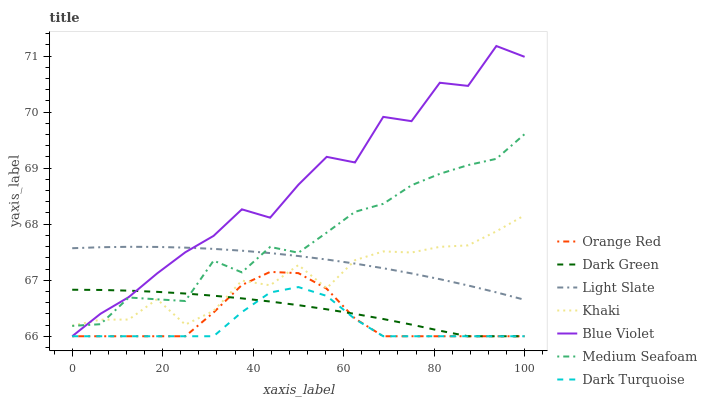Does Light Slate have the minimum area under the curve?
Answer yes or no. No. Does Light Slate have the maximum area under the curve?
Answer yes or no. No. Is Dark Turquoise the smoothest?
Answer yes or no. No. Is Dark Turquoise the roughest?
Answer yes or no. No. Does Light Slate have the lowest value?
Answer yes or no. No. Does Light Slate have the highest value?
Answer yes or no. No. Is Dark Turquoise less than Light Slate?
Answer yes or no. Yes. Is Light Slate greater than Dark Turquoise?
Answer yes or no. Yes. Does Dark Turquoise intersect Light Slate?
Answer yes or no. No. 